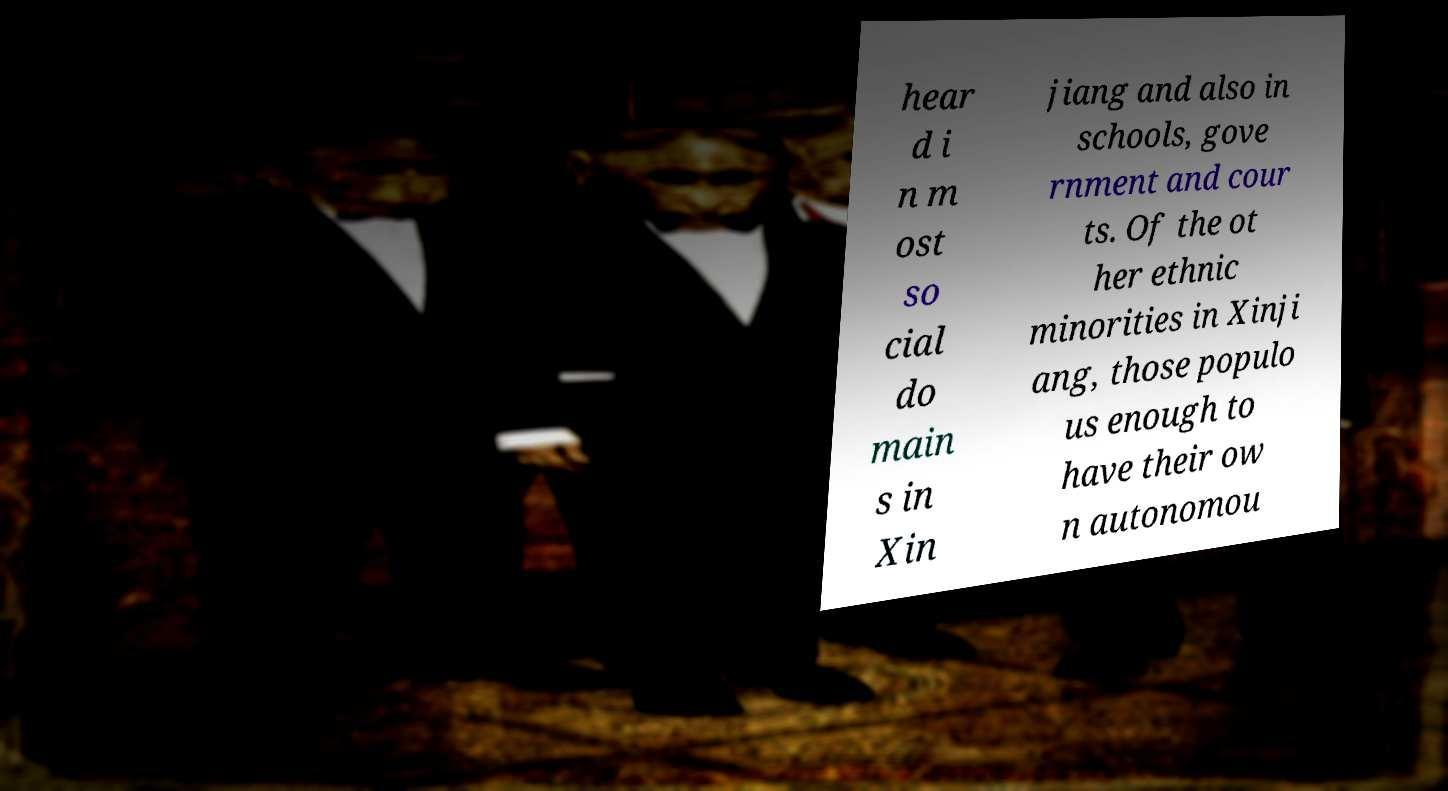Please identify and transcribe the text found in this image. hear d i n m ost so cial do main s in Xin jiang and also in schools, gove rnment and cour ts. Of the ot her ethnic minorities in Xinji ang, those populo us enough to have their ow n autonomou 